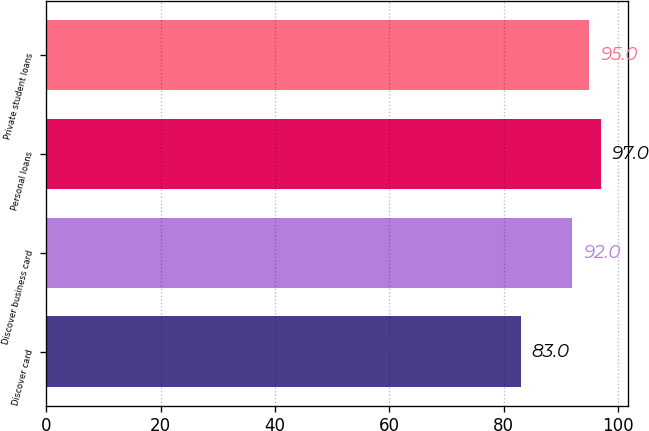<chart> <loc_0><loc_0><loc_500><loc_500><bar_chart><fcel>Discover card<fcel>Discover business card<fcel>Personal loans<fcel>Private student loans<nl><fcel>83<fcel>92<fcel>97<fcel>95<nl></chart> 